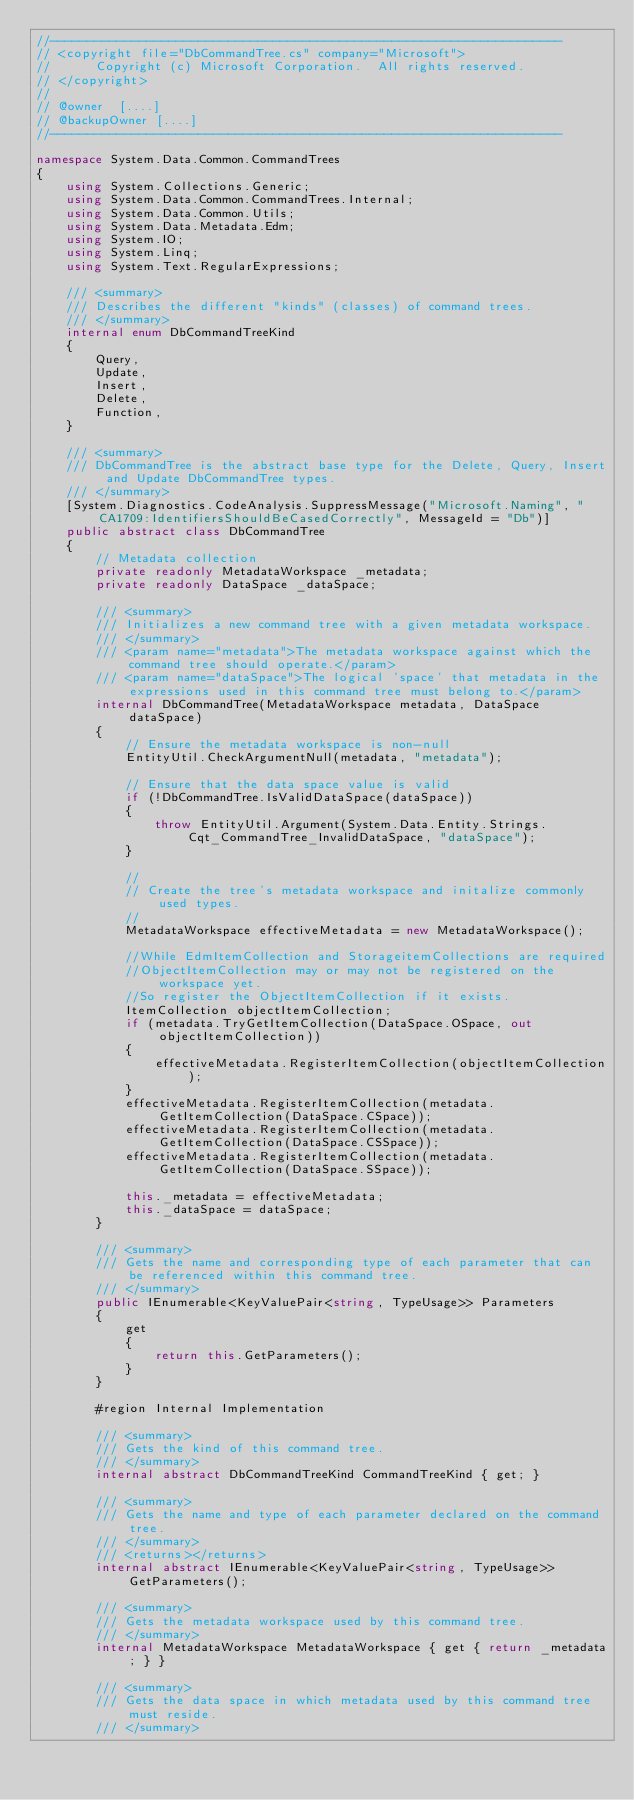<code> <loc_0><loc_0><loc_500><loc_500><_C#_>//---------------------------------------------------------------------
// <copyright file="DbCommandTree.cs" company="Microsoft">
//      Copyright (c) Microsoft Corporation.  All rights reserved.
// </copyright>
//
// @owner  [....]
// @backupOwner [....]
//---------------------------------------------------------------------

namespace System.Data.Common.CommandTrees
{
    using System.Collections.Generic;
    using System.Data.Common.CommandTrees.Internal;
    using System.Data.Common.Utils;
    using System.Data.Metadata.Edm;
    using System.IO;
    using System.Linq;
    using System.Text.RegularExpressions;

    /// <summary>
    /// Describes the different "kinds" (classes) of command trees.
    /// </summary>
    internal enum DbCommandTreeKind
    {
        Query,
        Update,
        Insert,
        Delete,
        Function,
    }

    /// <summary>
    /// DbCommandTree is the abstract base type for the Delete, Query, Insert and Update DbCommandTree types.
    /// </summary>
    [System.Diagnostics.CodeAnalysis.SuppressMessage("Microsoft.Naming", "CA1709:IdentifiersShouldBeCasedCorrectly", MessageId = "Db")]
    public abstract class DbCommandTree
    {      
        // Metadata collection
        private readonly MetadataWorkspace _metadata;
        private readonly DataSpace _dataSpace;
                
        /// <summary>
        /// Initializes a new command tree with a given metadata workspace.
        /// </summary>
        /// <param name="metadata">The metadata workspace against which the command tree should operate.</param>
        /// <param name="dataSpace">The logical 'space' that metadata in the expressions used in this command tree must belong to.</param>
        internal DbCommandTree(MetadataWorkspace metadata, DataSpace dataSpace)
        {
            // Ensure the metadata workspace is non-null
            EntityUtil.CheckArgumentNull(metadata, "metadata");

            // Ensure that the data space value is valid
            if (!DbCommandTree.IsValidDataSpace(dataSpace))
            {
                throw EntityUtil.Argument(System.Data.Entity.Strings.Cqt_CommandTree_InvalidDataSpace, "dataSpace");
            }

            //
            // Create the tree's metadata workspace and initalize commonly used types.
            //
            MetadataWorkspace effectiveMetadata = new MetadataWorkspace();
                
            //While EdmItemCollection and StorageitemCollections are required
            //ObjectItemCollection may or may not be registered on the workspace yet.
            //So register the ObjectItemCollection if it exists.
            ItemCollection objectItemCollection;
            if (metadata.TryGetItemCollection(DataSpace.OSpace, out objectItemCollection))
            {
                effectiveMetadata.RegisterItemCollection(objectItemCollection);
            }                
            effectiveMetadata.RegisterItemCollection(metadata.GetItemCollection(DataSpace.CSpace));
            effectiveMetadata.RegisterItemCollection(metadata.GetItemCollection(DataSpace.CSSpace));
            effectiveMetadata.RegisterItemCollection(metadata.GetItemCollection(DataSpace.SSpace));

            this._metadata = effectiveMetadata;
            this._dataSpace = dataSpace;
        }
                                        
        /// <summary>
        /// Gets the name and corresponding type of each parameter that can be referenced within this command tree.
        /// </summary>
        public IEnumerable<KeyValuePair<string, TypeUsage>> Parameters
        {
            get
            {
                return this.GetParameters();
            }
        }
                
        #region Internal Implementation
        
        /// <summary>
        /// Gets the kind of this command tree.
        /// </summary>
        internal abstract DbCommandTreeKind CommandTreeKind { get; }

        /// <summary>
        /// Gets the name and type of each parameter declared on the command tree.
        /// </summary>
        /// <returns></returns>
        internal abstract IEnumerable<KeyValuePair<string, TypeUsage>> GetParameters();
        
        /// <summary>
        /// Gets the metadata workspace used by this command tree.
        /// </summary>
        internal MetadataWorkspace MetadataWorkspace { get { return _metadata; } }

        /// <summary>
        /// Gets the data space in which metadata used by this command tree must reside.
        /// </summary></code> 